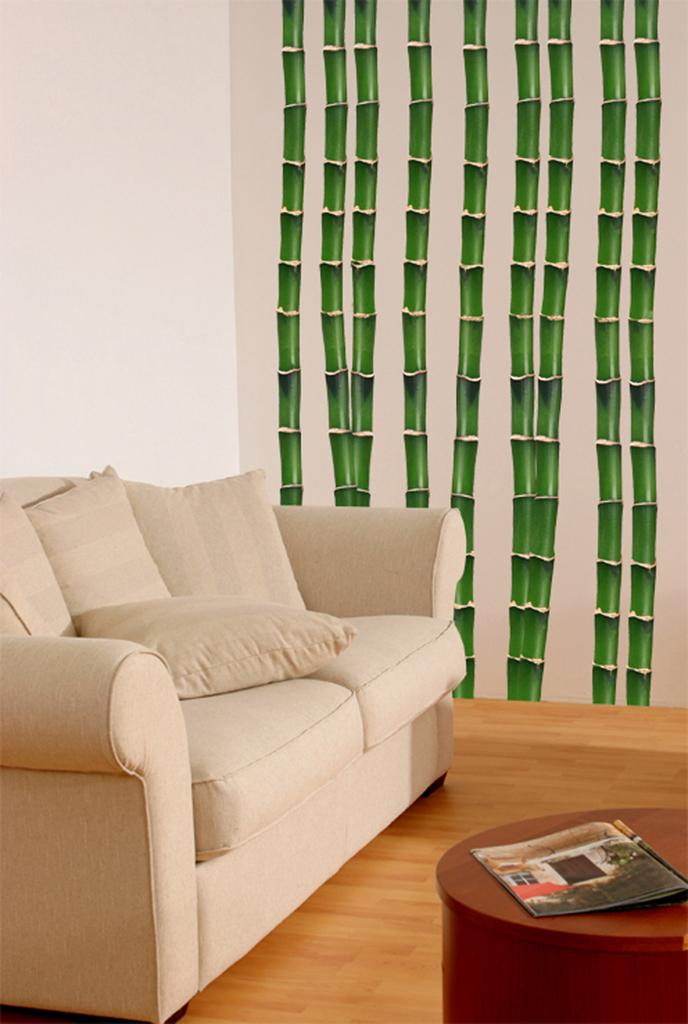What type of furniture is located on the left side of the image? There is a sofa on the left side of the image. What object can be seen on a table in the image? There is a book on a table in the image. Where is the rabbit hiding in the image? There is no rabbit present in the image. What type of lumber is used to construct the table in the image? The image does not provide information about the type of lumber used to construct the table. 